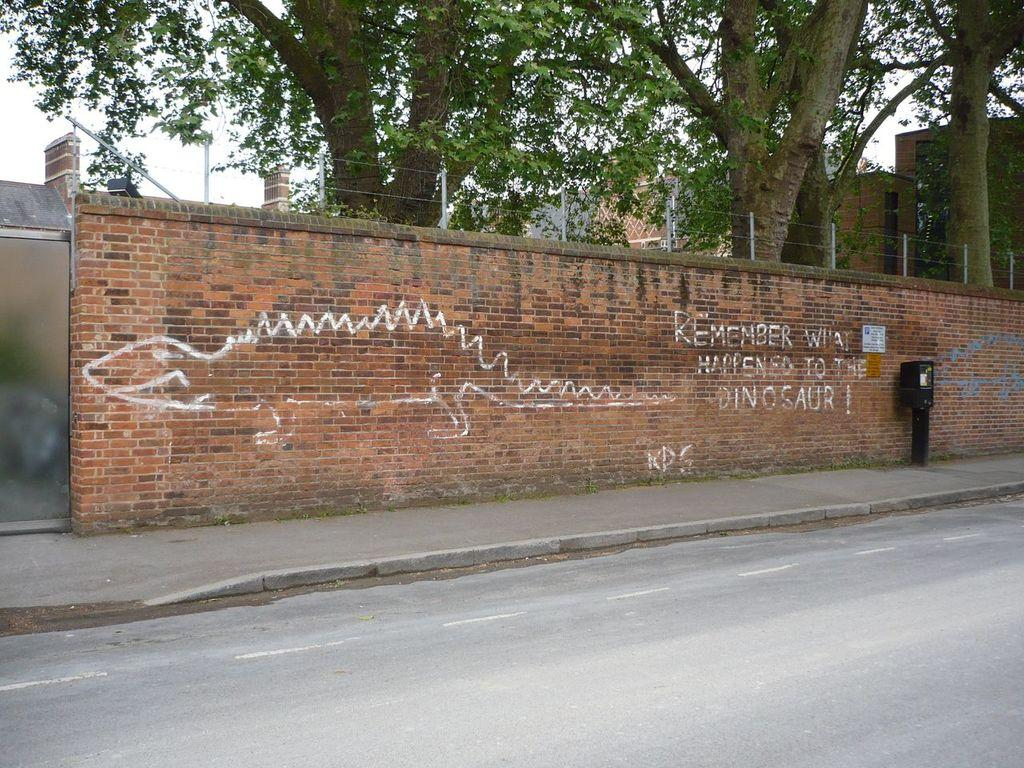What type of natural elements can be seen in the image? There are trees in the image. What type of man-made structures are present in the image? There are buildings in the image. What type of barrier can be seen in the image? There is fencing in the image. What type of wall is visible in the image? There is a brick wall in the image. What is the color of the object on the road? The object on the road is black in color. What is the color of the sky in the image? The sky is white in color. Can you hear the alarm going off in the image? There is no mention of an alarm in the image, so it cannot be heard. Is there a body of water visible in the image? There is no body of water mentioned in the image. Are there any flies present in the image? There is no mention of flies in the image. 